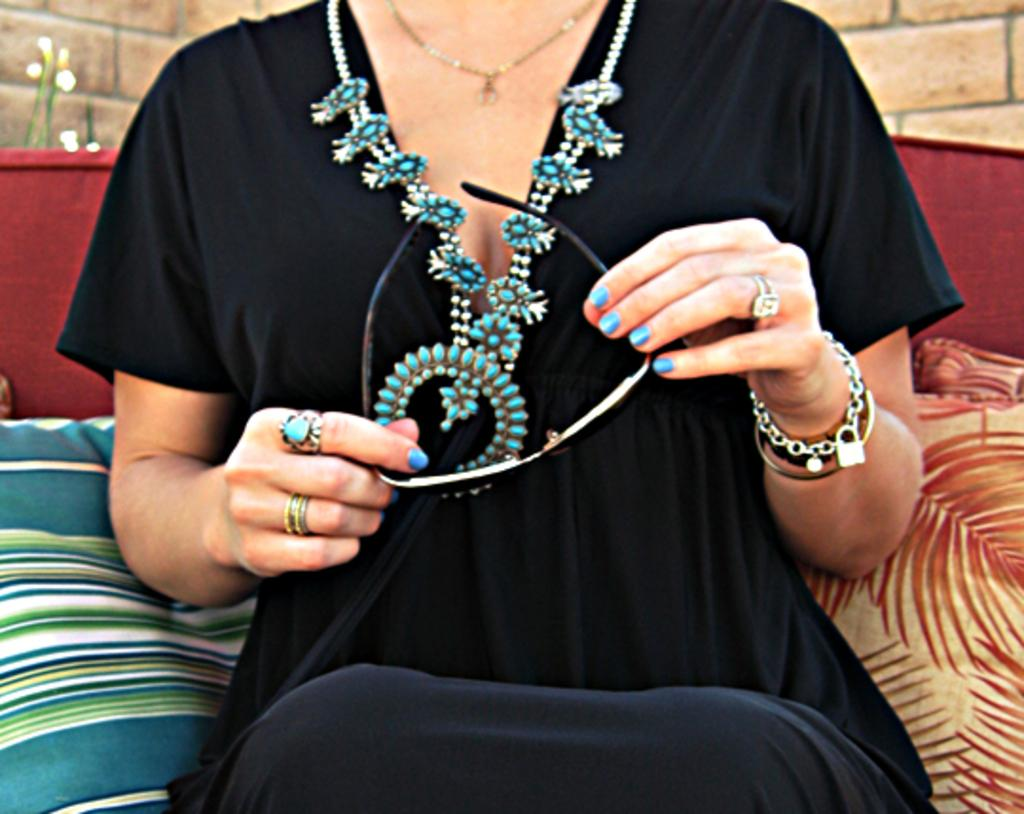Who is the main subject in the image? There is a woman in the image. What is the woman wearing? The woman is wearing a black dress. What is the woman holding in the image? The woman is holding spectacles. Where is the woman sitting? The woman is sitting on a sofa. What can be seen in the background of the image? There is a brick wall in the background of the image. What type of tub is visible in the image? There is no tub present in the image. Can you tell me the name of the actor sitting on the sofa in the image? The image does not depict an actor, but rather a woman sitting on the sofa. 